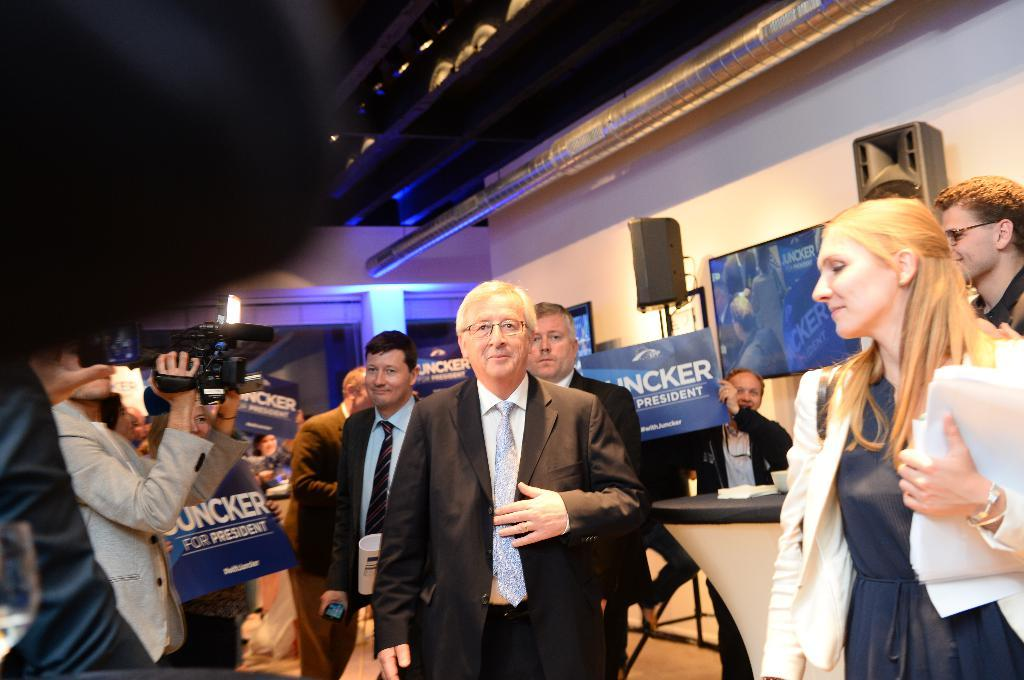What can be seen at the bottom of the image? There is a group of people standing at the bottom of the image. What is visible in the background of the image? There is a wall in the background of the image, as well as other objects. How many tomatoes are being held by the girls in the image? There are no girls or tomatoes present in the image. What type of business is being conducted by the group of people in the image? There is no indication of any business activity in the image; it simply shows a group of people standing together. 